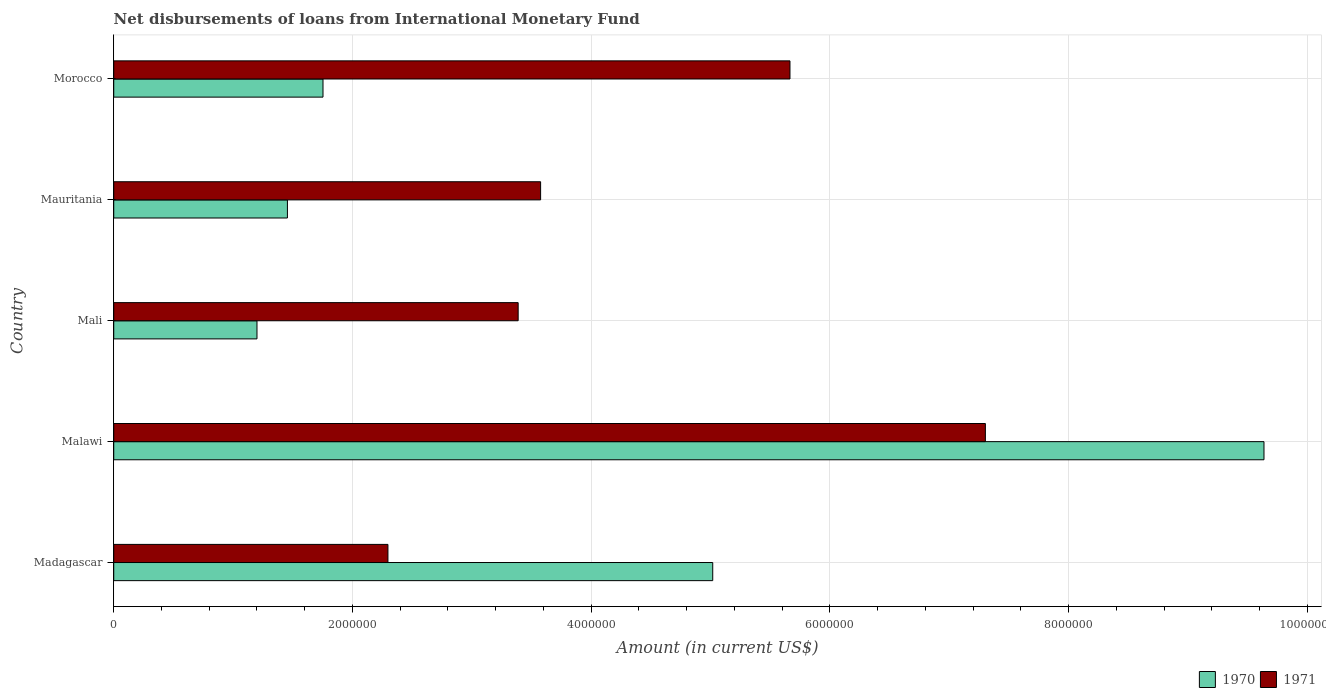How many different coloured bars are there?
Your answer should be compact. 2. Are the number of bars on each tick of the Y-axis equal?
Your response must be concise. Yes. How many bars are there on the 5th tick from the top?
Your answer should be very brief. 2. What is the label of the 3rd group of bars from the top?
Provide a short and direct response. Mali. In how many cases, is the number of bars for a given country not equal to the number of legend labels?
Provide a succinct answer. 0. What is the amount of loans disbursed in 1971 in Mauritania?
Provide a succinct answer. 3.58e+06. Across all countries, what is the maximum amount of loans disbursed in 1971?
Keep it short and to the point. 7.30e+06. Across all countries, what is the minimum amount of loans disbursed in 1970?
Offer a very short reply. 1.20e+06. In which country was the amount of loans disbursed in 1970 maximum?
Keep it short and to the point. Malawi. In which country was the amount of loans disbursed in 1971 minimum?
Provide a short and direct response. Madagascar. What is the total amount of loans disbursed in 1970 in the graph?
Make the answer very short. 1.91e+07. What is the difference between the amount of loans disbursed in 1971 in Malawi and that in Mali?
Your answer should be very brief. 3.91e+06. What is the difference between the amount of loans disbursed in 1970 in Morocco and the amount of loans disbursed in 1971 in Mauritania?
Your answer should be very brief. -1.82e+06. What is the average amount of loans disbursed in 1971 per country?
Ensure brevity in your answer.  4.45e+06. What is the difference between the amount of loans disbursed in 1971 and amount of loans disbursed in 1970 in Mali?
Provide a succinct answer. 2.19e+06. What is the ratio of the amount of loans disbursed in 1971 in Mali to that in Morocco?
Provide a short and direct response. 0.6. Is the amount of loans disbursed in 1971 in Madagascar less than that in Mali?
Offer a very short reply. Yes. What is the difference between the highest and the second highest amount of loans disbursed in 1970?
Provide a succinct answer. 4.62e+06. What is the difference between the highest and the lowest amount of loans disbursed in 1970?
Your response must be concise. 8.44e+06. How many countries are there in the graph?
Keep it short and to the point. 5. Does the graph contain any zero values?
Give a very brief answer. No. Does the graph contain grids?
Keep it short and to the point. Yes. How many legend labels are there?
Offer a very short reply. 2. What is the title of the graph?
Ensure brevity in your answer.  Net disbursements of loans from International Monetary Fund. Does "1961" appear as one of the legend labels in the graph?
Provide a succinct answer. No. What is the label or title of the Y-axis?
Offer a very short reply. Country. What is the Amount (in current US$) of 1970 in Madagascar?
Give a very brief answer. 5.02e+06. What is the Amount (in current US$) in 1971 in Madagascar?
Keep it short and to the point. 2.30e+06. What is the Amount (in current US$) in 1970 in Malawi?
Your answer should be compact. 9.64e+06. What is the Amount (in current US$) of 1971 in Malawi?
Offer a very short reply. 7.30e+06. What is the Amount (in current US$) of 1970 in Mali?
Your answer should be very brief. 1.20e+06. What is the Amount (in current US$) in 1971 in Mali?
Your response must be concise. 3.39e+06. What is the Amount (in current US$) in 1970 in Mauritania?
Your answer should be compact. 1.46e+06. What is the Amount (in current US$) in 1971 in Mauritania?
Give a very brief answer. 3.58e+06. What is the Amount (in current US$) of 1970 in Morocco?
Ensure brevity in your answer.  1.75e+06. What is the Amount (in current US$) in 1971 in Morocco?
Keep it short and to the point. 5.66e+06. Across all countries, what is the maximum Amount (in current US$) in 1970?
Offer a terse response. 9.64e+06. Across all countries, what is the maximum Amount (in current US$) of 1971?
Your answer should be compact. 7.30e+06. Across all countries, what is the minimum Amount (in current US$) in 1970?
Keep it short and to the point. 1.20e+06. Across all countries, what is the minimum Amount (in current US$) of 1971?
Ensure brevity in your answer.  2.30e+06. What is the total Amount (in current US$) of 1970 in the graph?
Your response must be concise. 1.91e+07. What is the total Amount (in current US$) of 1971 in the graph?
Your answer should be compact. 2.22e+07. What is the difference between the Amount (in current US$) in 1970 in Madagascar and that in Malawi?
Your response must be concise. -4.62e+06. What is the difference between the Amount (in current US$) in 1971 in Madagascar and that in Malawi?
Your answer should be compact. -5.00e+06. What is the difference between the Amount (in current US$) of 1970 in Madagascar and that in Mali?
Keep it short and to the point. 3.82e+06. What is the difference between the Amount (in current US$) of 1971 in Madagascar and that in Mali?
Ensure brevity in your answer.  -1.09e+06. What is the difference between the Amount (in current US$) in 1970 in Madagascar and that in Mauritania?
Your answer should be compact. 3.56e+06. What is the difference between the Amount (in current US$) of 1971 in Madagascar and that in Mauritania?
Make the answer very short. -1.28e+06. What is the difference between the Amount (in current US$) of 1970 in Madagascar and that in Morocco?
Keep it short and to the point. 3.26e+06. What is the difference between the Amount (in current US$) of 1971 in Madagascar and that in Morocco?
Your answer should be very brief. -3.37e+06. What is the difference between the Amount (in current US$) in 1970 in Malawi and that in Mali?
Keep it short and to the point. 8.44e+06. What is the difference between the Amount (in current US$) of 1971 in Malawi and that in Mali?
Keep it short and to the point. 3.91e+06. What is the difference between the Amount (in current US$) of 1970 in Malawi and that in Mauritania?
Provide a succinct answer. 8.18e+06. What is the difference between the Amount (in current US$) of 1971 in Malawi and that in Mauritania?
Provide a succinct answer. 3.73e+06. What is the difference between the Amount (in current US$) of 1970 in Malawi and that in Morocco?
Provide a short and direct response. 7.88e+06. What is the difference between the Amount (in current US$) of 1971 in Malawi and that in Morocco?
Offer a terse response. 1.64e+06. What is the difference between the Amount (in current US$) in 1970 in Mali and that in Mauritania?
Your response must be concise. -2.55e+05. What is the difference between the Amount (in current US$) of 1971 in Mali and that in Mauritania?
Provide a short and direct response. -1.88e+05. What is the difference between the Amount (in current US$) of 1970 in Mali and that in Morocco?
Make the answer very short. -5.53e+05. What is the difference between the Amount (in current US$) in 1971 in Mali and that in Morocco?
Ensure brevity in your answer.  -2.28e+06. What is the difference between the Amount (in current US$) of 1970 in Mauritania and that in Morocco?
Offer a terse response. -2.98e+05. What is the difference between the Amount (in current US$) of 1971 in Mauritania and that in Morocco?
Give a very brief answer. -2.09e+06. What is the difference between the Amount (in current US$) of 1970 in Madagascar and the Amount (in current US$) of 1971 in Malawi?
Provide a succinct answer. -2.28e+06. What is the difference between the Amount (in current US$) of 1970 in Madagascar and the Amount (in current US$) of 1971 in Mali?
Provide a short and direct response. 1.63e+06. What is the difference between the Amount (in current US$) in 1970 in Madagascar and the Amount (in current US$) in 1971 in Mauritania?
Ensure brevity in your answer.  1.44e+06. What is the difference between the Amount (in current US$) of 1970 in Madagascar and the Amount (in current US$) of 1971 in Morocco?
Your answer should be very brief. -6.47e+05. What is the difference between the Amount (in current US$) in 1970 in Malawi and the Amount (in current US$) in 1971 in Mali?
Offer a terse response. 6.25e+06. What is the difference between the Amount (in current US$) in 1970 in Malawi and the Amount (in current US$) in 1971 in Mauritania?
Offer a terse response. 6.06e+06. What is the difference between the Amount (in current US$) of 1970 in Malawi and the Amount (in current US$) of 1971 in Morocco?
Keep it short and to the point. 3.97e+06. What is the difference between the Amount (in current US$) in 1970 in Mali and the Amount (in current US$) in 1971 in Mauritania?
Ensure brevity in your answer.  -2.38e+06. What is the difference between the Amount (in current US$) in 1970 in Mali and the Amount (in current US$) in 1971 in Morocco?
Give a very brief answer. -4.46e+06. What is the difference between the Amount (in current US$) in 1970 in Mauritania and the Amount (in current US$) in 1971 in Morocco?
Your answer should be very brief. -4.21e+06. What is the average Amount (in current US$) of 1970 per country?
Provide a succinct answer. 3.81e+06. What is the average Amount (in current US$) of 1971 per country?
Ensure brevity in your answer.  4.45e+06. What is the difference between the Amount (in current US$) of 1970 and Amount (in current US$) of 1971 in Madagascar?
Your response must be concise. 2.72e+06. What is the difference between the Amount (in current US$) in 1970 and Amount (in current US$) in 1971 in Malawi?
Offer a very short reply. 2.33e+06. What is the difference between the Amount (in current US$) of 1970 and Amount (in current US$) of 1971 in Mali?
Offer a terse response. -2.19e+06. What is the difference between the Amount (in current US$) of 1970 and Amount (in current US$) of 1971 in Mauritania?
Ensure brevity in your answer.  -2.12e+06. What is the difference between the Amount (in current US$) of 1970 and Amount (in current US$) of 1971 in Morocco?
Ensure brevity in your answer.  -3.91e+06. What is the ratio of the Amount (in current US$) in 1970 in Madagascar to that in Malawi?
Provide a succinct answer. 0.52. What is the ratio of the Amount (in current US$) in 1971 in Madagascar to that in Malawi?
Provide a succinct answer. 0.31. What is the ratio of the Amount (in current US$) in 1970 in Madagascar to that in Mali?
Give a very brief answer. 4.18. What is the ratio of the Amount (in current US$) in 1971 in Madagascar to that in Mali?
Keep it short and to the point. 0.68. What is the ratio of the Amount (in current US$) in 1970 in Madagascar to that in Mauritania?
Offer a very short reply. 3.45. What is the ratio of the Amount (in current US$) of 1971 in Madagascar to that in Mauritania?
Give a very brief answer. 0.64. What is the ratio of the Amount (in current US$) of 1970 in Madagascar to that in Morocco?
Your response must be concise. 2.86. What is the ratio of the Amount (in current US$) of 1971 in Madagascar to that in Morocco?
Make the answer very short. 0.41. What is the ratio of the Amount (in current US$) in 1970 in Malawi to that in Mali?
Offer a very short reply. 8.03. What is the ratio of the Amount (in current US$) in 1971 in Malawi to that in Mali?
Offer a very short reply. 2.16. What is the ratio of the Amount (in current US$) in 1970 in Malawi to that in Mauritania?
Provide a short and direct response. 6.62. What is the ratio of the Amount (in current US$) in 1971 in Malawi to that in Mauritania?
Provide a short and direct response. 2.04. What is the ratio of the Amount (in current US$) in 1970 in Malawi to that in Morocco?
Your response must be concise. 5.5. What is the ratio of the Amount (in current US$) in 1971 in Malawi to that in Morocco?
Provide a short and direct response. 1.29. What is the ratio of the Amount (in current US$) in 1970 in Mali to that in Mauritania?
Make the answer very short. 0.82. What is the ratio of the Amount (in current US$) of 1970 in Mali to that in Morocco?
Your answer should be very brief. 0.68. What is the ratio of the Amount (in current US$) of 1971 in Mali to that in Morocco?
Ensure brevity in your answer.  0.6. What is the ratio of the Amount (in current US$) of 1970 in Mauritania to that in Morocco?
Give a very brief answer. 0.83. What is the ratio of the Amount (in current US$) of 1971 in Mauritania to that in Morocco?
Provide a succinct answer. 0.63. What is the difference between the highest and the second highest Amount (in current US$) in 1970?
Provide a succinct answer. 4.62e+06. What is the difference between the highest and the second highest Amount (in current US$) of 1971?
Provide a succinct answer. 1.64e+06. What is the difference between the highest and the lowest Amount (in current US$) in 1970?
Provide a succinct answer. 8.44e+06. What is the difference between the highest and the lowest Amount (in current US$) in 1971?
Offer a terse response. 5.00e+06. 